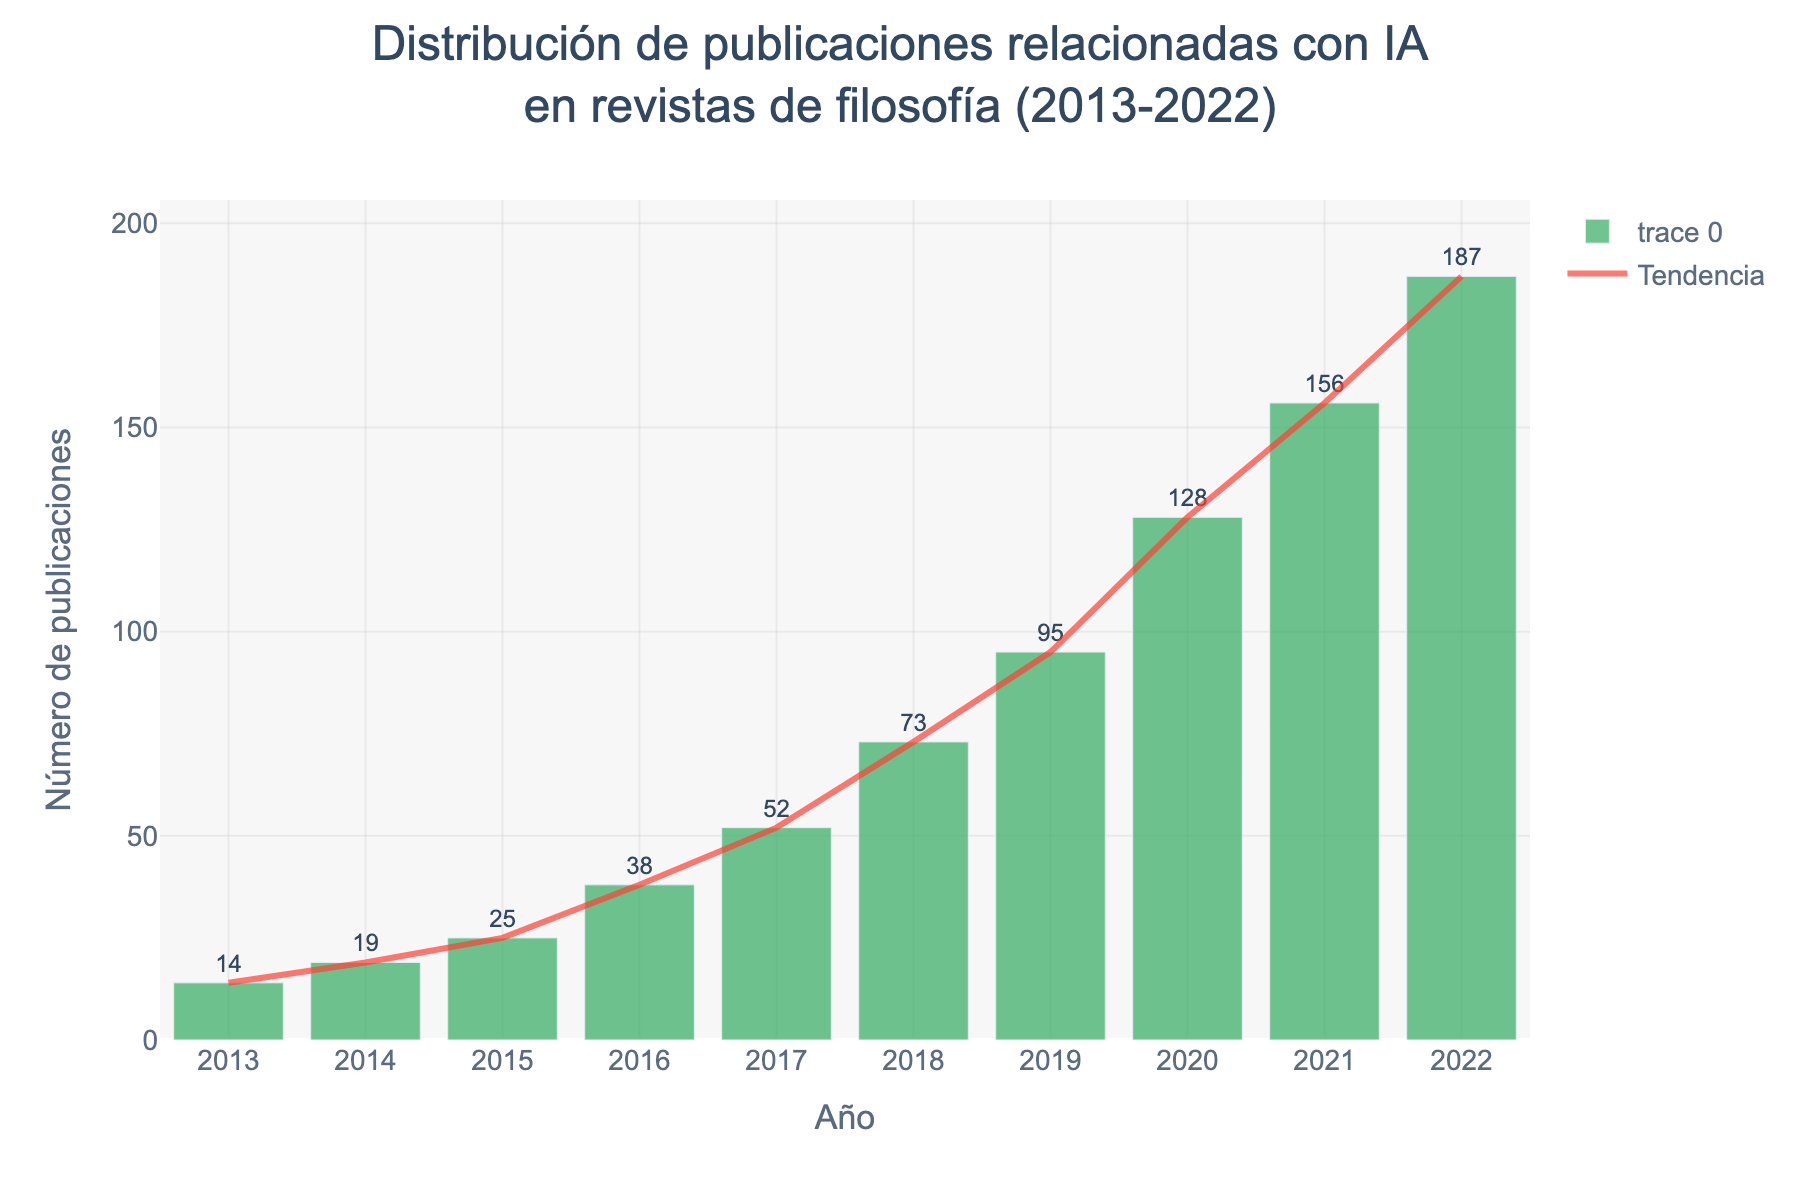What is the title of the histogram? The title is displayed at the top of the histogram, indicating the subject of the data.
Answer: Distribución de publicaciones relacionadas con IA en revistas de filosofía (2013-2022) How many AI-related publications were there in 2015? Look at the bar corresponding to the year 2015 and check the value on the y-axis.
Answer: 25 Which year had the highest number of AI-related publications? Compare the height of the bars for each year and identify the tallest one.
Answer: 2022 How many more AI-related publications were there in 2020 compared to 2017? Find the values for both years and subtract the number of publications in 2017 from the number in 2020. 128 - 52 = 76
Answer: 76 Describe the trend of AI-related publications from 2013 to 2022. Observe the general shape and direction of the bar heights and the trend line. The trend shows a steady increase.
Answer: Steadily increasing What was the total number of AI-related publications between 2018 and 2020? Sum the values for the years 2018 to 2020: 73 + 95 + 128 = 296
Answer: 296 In which year did the number of publications first exceed 100? Identify the first year where the bar's height crosses the 100-mark on the y-axis.
Answer: 2019 Compare the number of publications in 2022 to those in 2013. Divide the number of publications in 2022 by those in 2013 and interpret the result: 187 / 14 ≈ 13.36. The number in 2022 is over 13 times greater than in 2013.
Answer: Over 13 times greater What can be inferred about the attention towards AI in philosophy journals based on the histogram? Analyze the trend of increasing publications over the years. The increasing number indicates growing interest and attention towards AI in philosophy.
Answer: Growing interest 